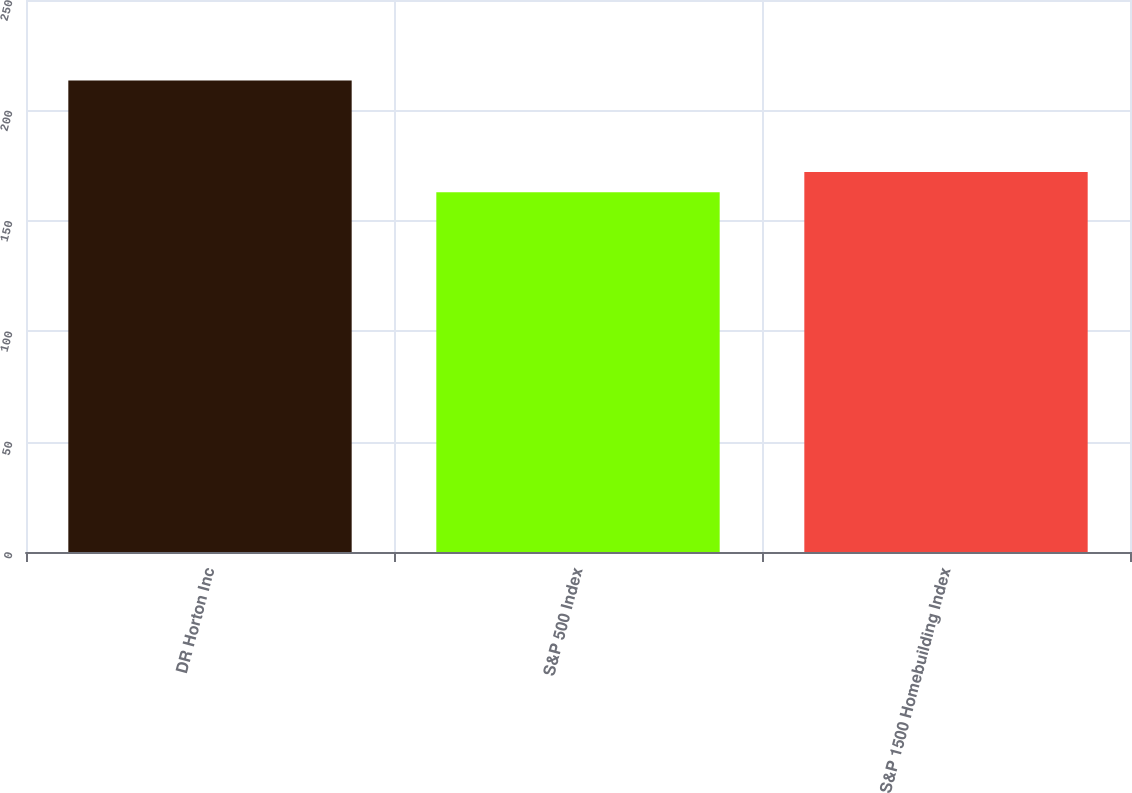Convert chart to OTSL. <chart><loc_0><loc_0><loc_500><loc_500><bar_chart><fcel>DR Horton Inc<fcel>S&P 500 Index<fcel>S&P 1500 Homebuilding Index<nl><fcel>213.53<fcel>162.92<fcel>172.15<nl></chart> 